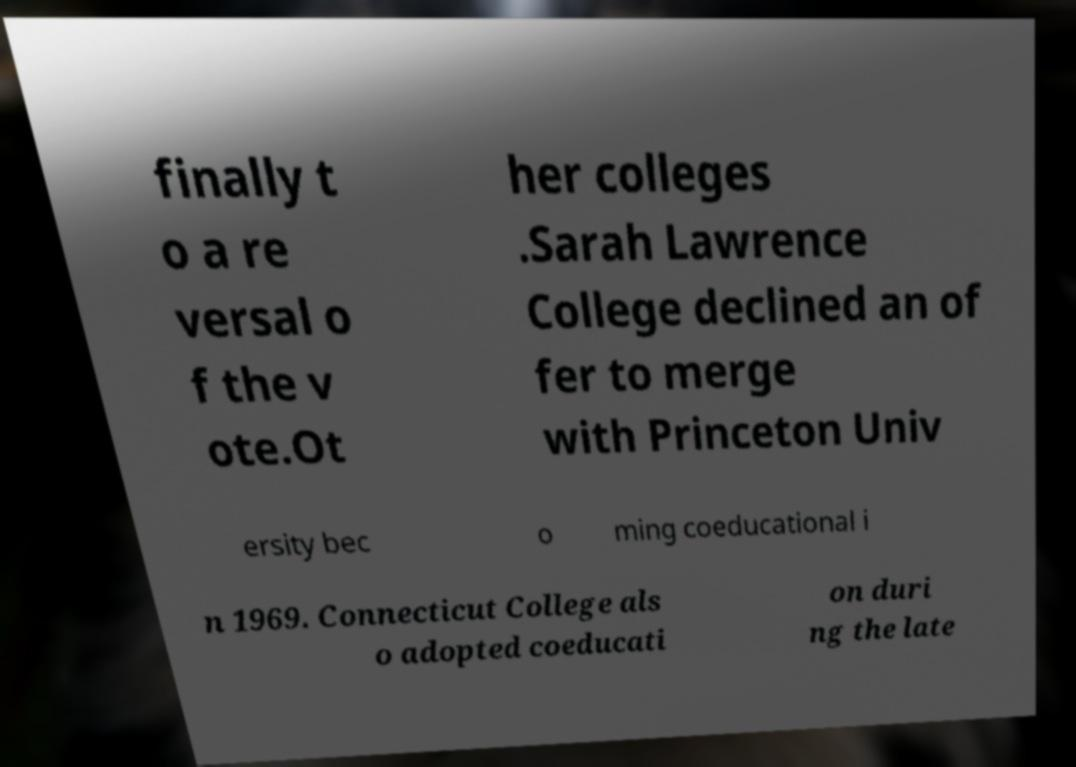For documentation purposes, I need the text within this image transcribed. Could you provide that? finally t o a re versal o f the v ote.Ot her colleges .Sarah Lawrence College declined an of fer to merge with Princeton Univ ersity bec o ming coeducational i n 1969. Connecticut College als o adopted coeducati on duri ng the late 